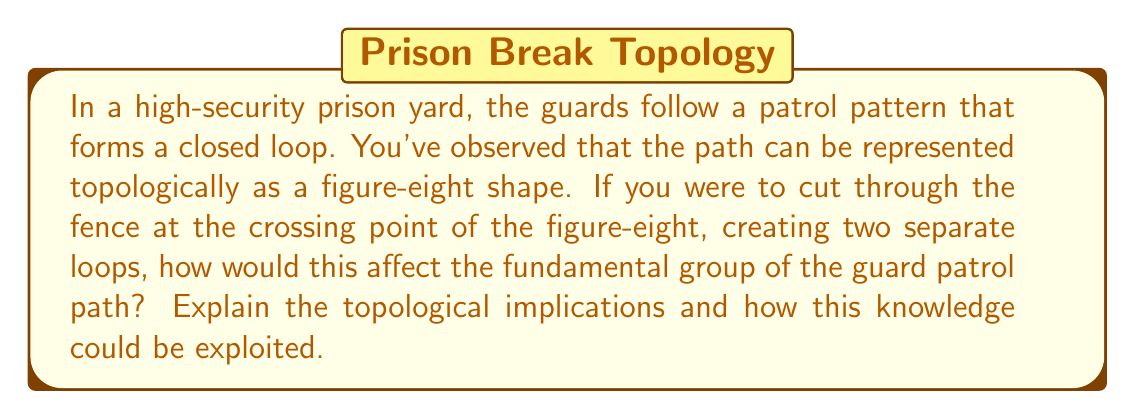Teach me how to tackle this problem. Let's approach this step-by-step:

1) Initially, the guard patrol pattern forms a figure-eight shape. Topologically, this is equivalent to a wedge sum of two circles, often denoted as $S^1 \vee S^1$.

2) The fundamental group of a figure-eight is the free group on two generators, typically written as:

   $$\pi_1(S^1 \vee S^1) \cong F_2 = \langle a, b \rangle$$

   where $a$ and $b$ represent loops around each circle of the figure-eight.

3) When we cut through the crossing point, we're essentially separating the figure-eight into two distinct circles. Topologically, this operation is called a disjoint union, denoted as $S^1 \sqcup S^1$.

4) The fundamental group of a disjoint union of spaces is the direct product of their fundamental groups. For two circles, this gives us:

   $$\pi_1(S^1 \sqcup S^1) \cong \mathbb{Z} \times \mathbb{Z}$$

   where $\mathbb{Z}$ is the group of integers under addition.

5) The change from $F_2$ to $\mathbb{Z} \times \mathbb{Z}$ has significant implications:
   - In $F_2$, the generators $a$ and $b$ can be combined in any order, allowing for complex paths.
   - In $\mathbb{Z} \times \mathbb{Z}$, the two components are independent and commutative.

6) Exploiting this change:
   - The original pattern allowed guards to switch between loops at the crossing point.
   - After cutting, guards are confined to their respective loops.
   - This reduces the complexity of the patrol pattern and creates two isolated areas.
   - It becomes easier to predict guard movements and potentially find gaps in coverage.

[asy]
unitsize(1cm);

// Figure-eight
draw((0,0)..(1,1)..(2,0)..(1,-1)..cycle);
draw((2,0)..(3,1)..(4,0)..(3,-1)..cycle);

// Separated circles
draw((6,0)..(7,1)..(8,0)..(7,-1)..cycle);
draw((10,0)..(11,1)..(12,0)..(11,-1)..cycle);

label("Original", (2,-1.5));
label("After cutting", (9,-1.5));

draw((5,0)--(5.5,0), arrow=Arrow(TeXHead));
[/asy]
Answer: Cutting the figure-eight at the crossing point changes the fundamental group from the free group on two generators ($F_2$) to the direct product of two infinite cyclic groups ($\mathbb{Z} \times \mathbb{Z}$). This simplifies the patrol pattern, making guard movements more predictable and creating isolated areas, which could potentially be exploited to find gaps in security coverage. 